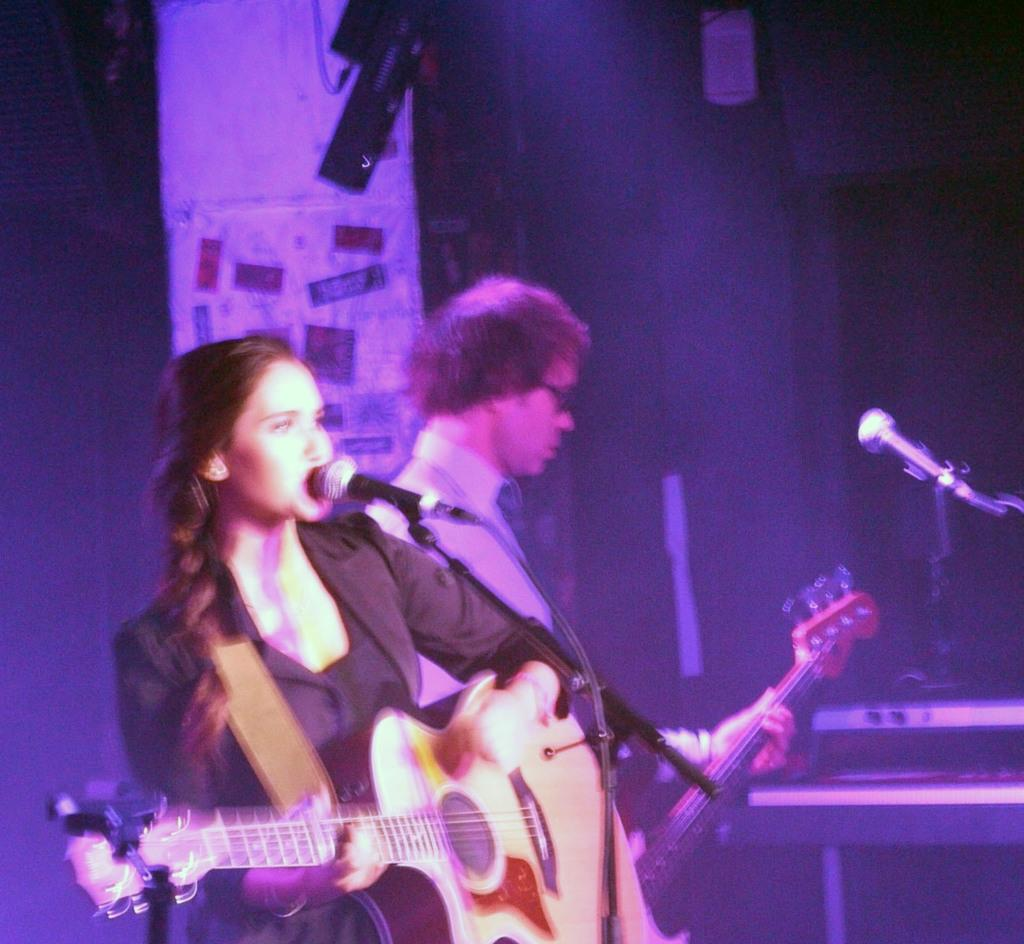What is the lady in the image doing? The lady in the image is singing through a mic and playing a guitar. Can you describe the person in the background of the image? The person in the background is playing a guitar and there is a mic in front of them. How many people are playing a guitar in the image? There are two people playing a guitar in the image, the lady and the person in the background. What type of kettle can be seen in the image? There is no kettle present in the image. What is the lady using to support her chin while singing? The lady is not using anything to support her chin while singing; she is holding a guitar and a mic. 